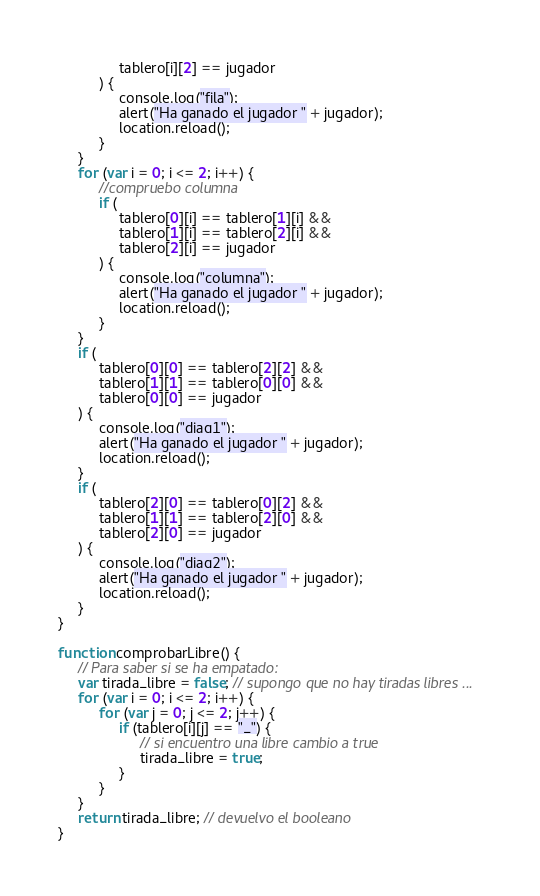<code> <loc_0><loc_0><loc_500><loc_500><_JavaScript_>               tablero[i][2] == jugador
          ) {
               console.log("fila");
               alert("Ha ganado el jugador " + jugador);
               location.reload();
          }
     }
     for (var i = 0; i <= 2; i++) {
          //compruebo columna
          if (
               tablero[0][i] == tablero[1][i] &&
               tablero[1][i] == tablero[2][i] &&
               tablero[2][i] == jugador
          ) {
               console.log("columna");
               alert("Ha ganado el jugador " + jugador);
               location.reload();
          }
     }
     if (
          tablero[0][0] == tablero[2][2] &&
          tablero[1][1] == tablero[0][0] &&
          tablero[0][0] == jugador
     ) {
          console.log("diag1");
          alert("Ha ganado el jugador " + jugador);
          location.reload();
     }
     if (
          tablero[2][0] == tablero[0][2] &&
          tablero[1][1] == tablero[2][0] &&
          tablero[2][0] == jugador
     ) {
          console.log("diag2");
          alert("Ha ganado el jugador " + jugador);
          location.reload();
     }
}

function comprobarLibre() {
     // Para saber si se ha empatado:
     var tirada_libre = false; // supongo que no hay tiradas libres ...
     for (var i = 0; i <= 2; i++) {
          for (var j = 0; j <= 2; j++) {
               if (tablero[i][j] == "_") {
                    // si encuentro una libre cambio a true
                    tirada_libre = true;
               }
          }
     }
     return tirada_libre; // devuelvo el booleano
}
</code> 